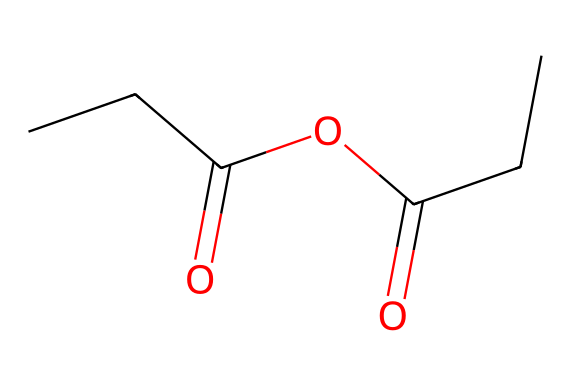How many carbon atoms are in propionic anhydride? By analyzing the provided SMILES representation, "CCC(=O)OC(=O)CC," we can count the number of carbon (C) atoms indicated. The first part "CCC" corresponds to three carbon atoms followed by two additional carbon atoms at the end, making a total of five carbon atoms.
Answer: five What is the total number of oxygen atoms in this molecule? In the SMILES structure, the two "O" symbols indicate the presence of two oxygen (O) atoms associated with the carbonyl groups (=O) and another oxygen connected to the ester bond (C-O-C). Therefore, adding these gives us a total of three oxygen atoms.
Answer: three What type of functional groups are present in propionic anhydride? Analyzing the structure, the molecule has both an anhydride group (two carbonyls connected by an oxygen), and it can also be classified as having ester characteristics due to the presence of the C-O bond. Thus, the functional groups present are anhydride and ester.
Answer: anhydride and ester What is the molecular formula of propionic anhydride? By using the counted atoms from the SMILES representation, we can summarize the counts: C=5, H=8 (from the bonded hydrogen atoms), O=3. Therefore, the complete molecular formula is C5H8O3.
Answer: C5H8O3 How does the molecular structure of propionic anhydride facilitate its use in woodcraft conservation? The presence of the anhydride functional group allows for reactivity with hydroxyl groups on wood surfaces, enabling it to form esters that help in protecting and preserving the materials. This reactivity is important in conservation applications.
Answer: reactivity with hydroxyl groups 